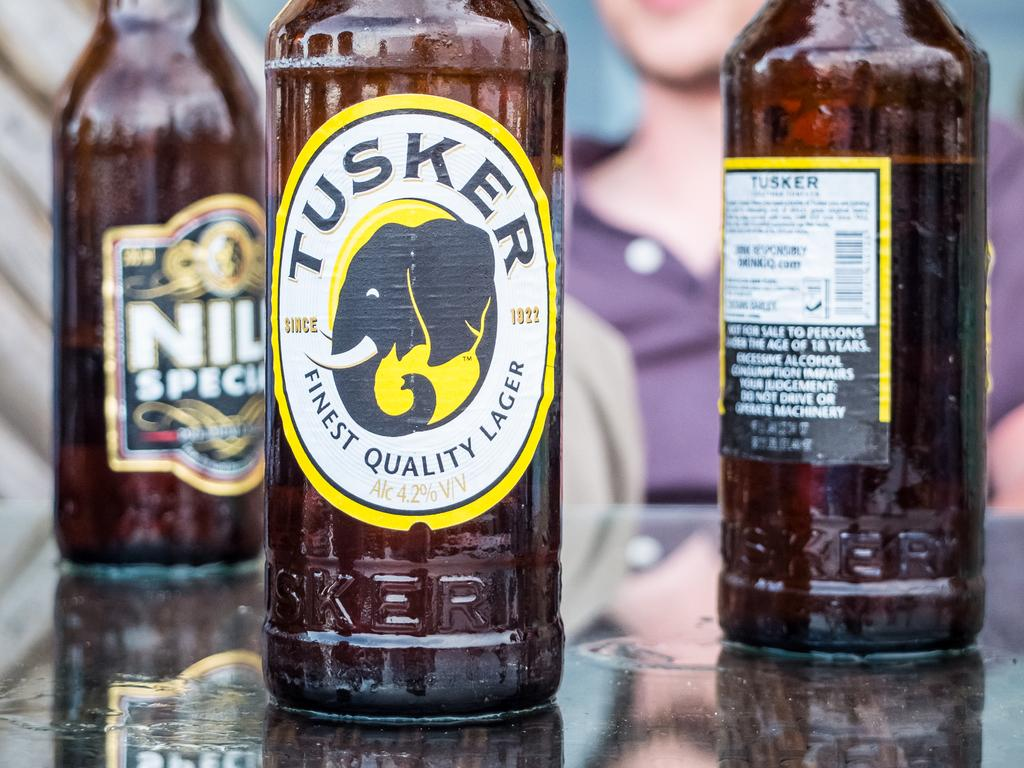<image>
Describe the image concisely. The Tusker bottle states it's a finest quality lager. 